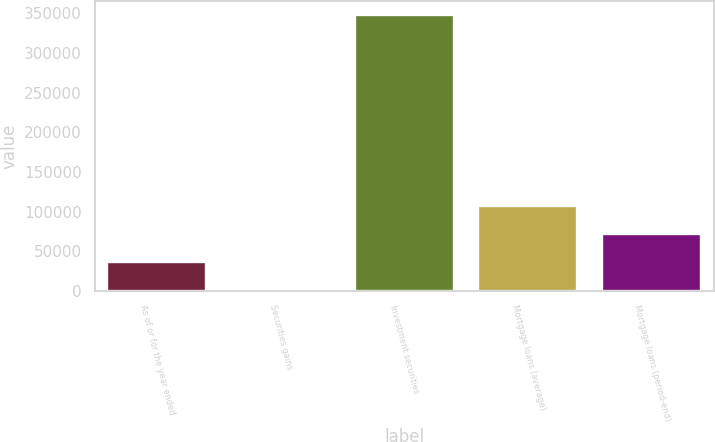<chart> <loc_0><loc_0><loc_500><loc_500><bar_chart><fcel>As of or for the year ended<fcel>Securities gains<fcel>Investment securities<fcel>Mortgage loans (average)<fcel>Mortgage loans (period-end)<nl><fcel>35964.3<fcel>659<fcel>347562<fcel>106575<fcel>71269.6<nl></chart> 